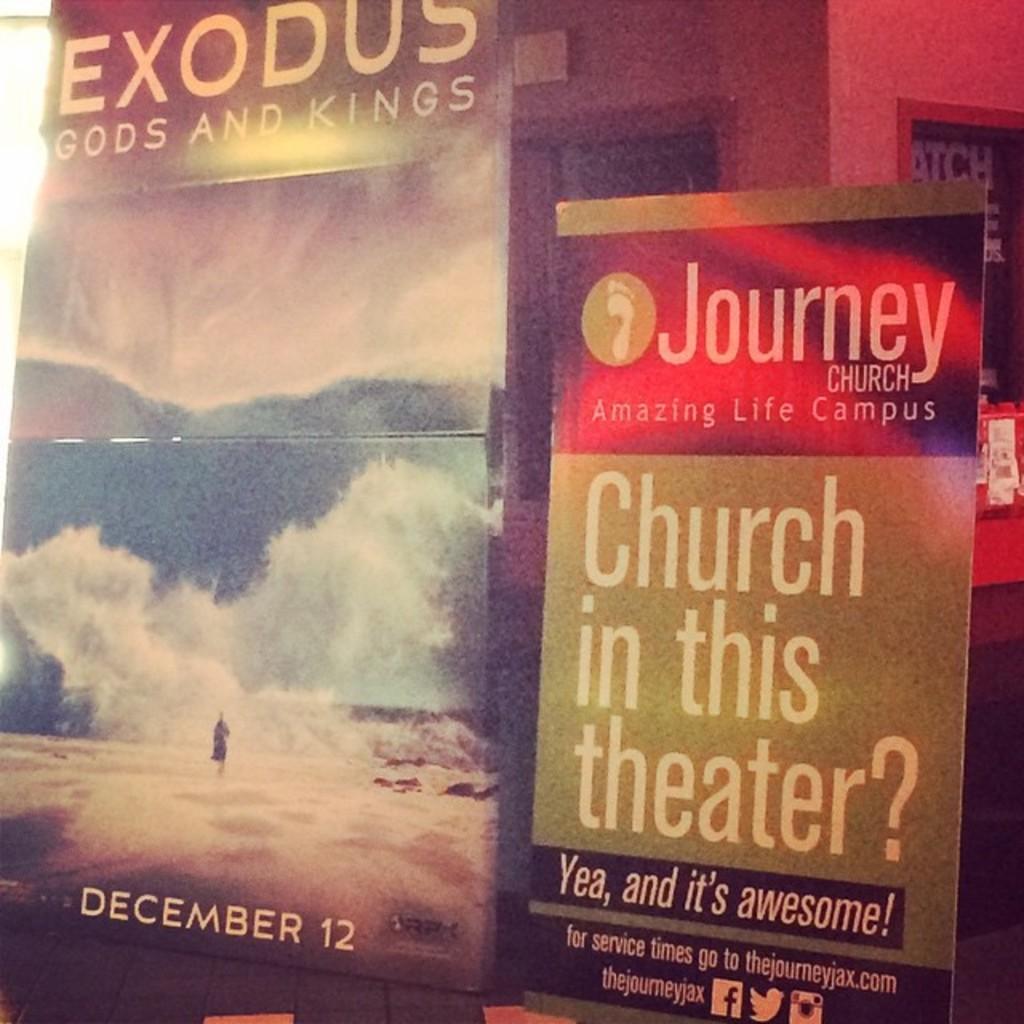What day is the show?
Your response must be concise. December 12. 